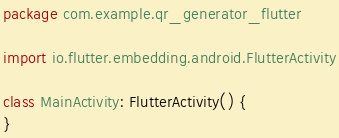<code> <loc_0><loc_0><loc_500><loc_500><_Kotlin_>package com.example.qr_generator_flutter

import io.flutter.embedding.android.FlutterActivity

class MainActivity: FlutterActivity() {
}
</code> 